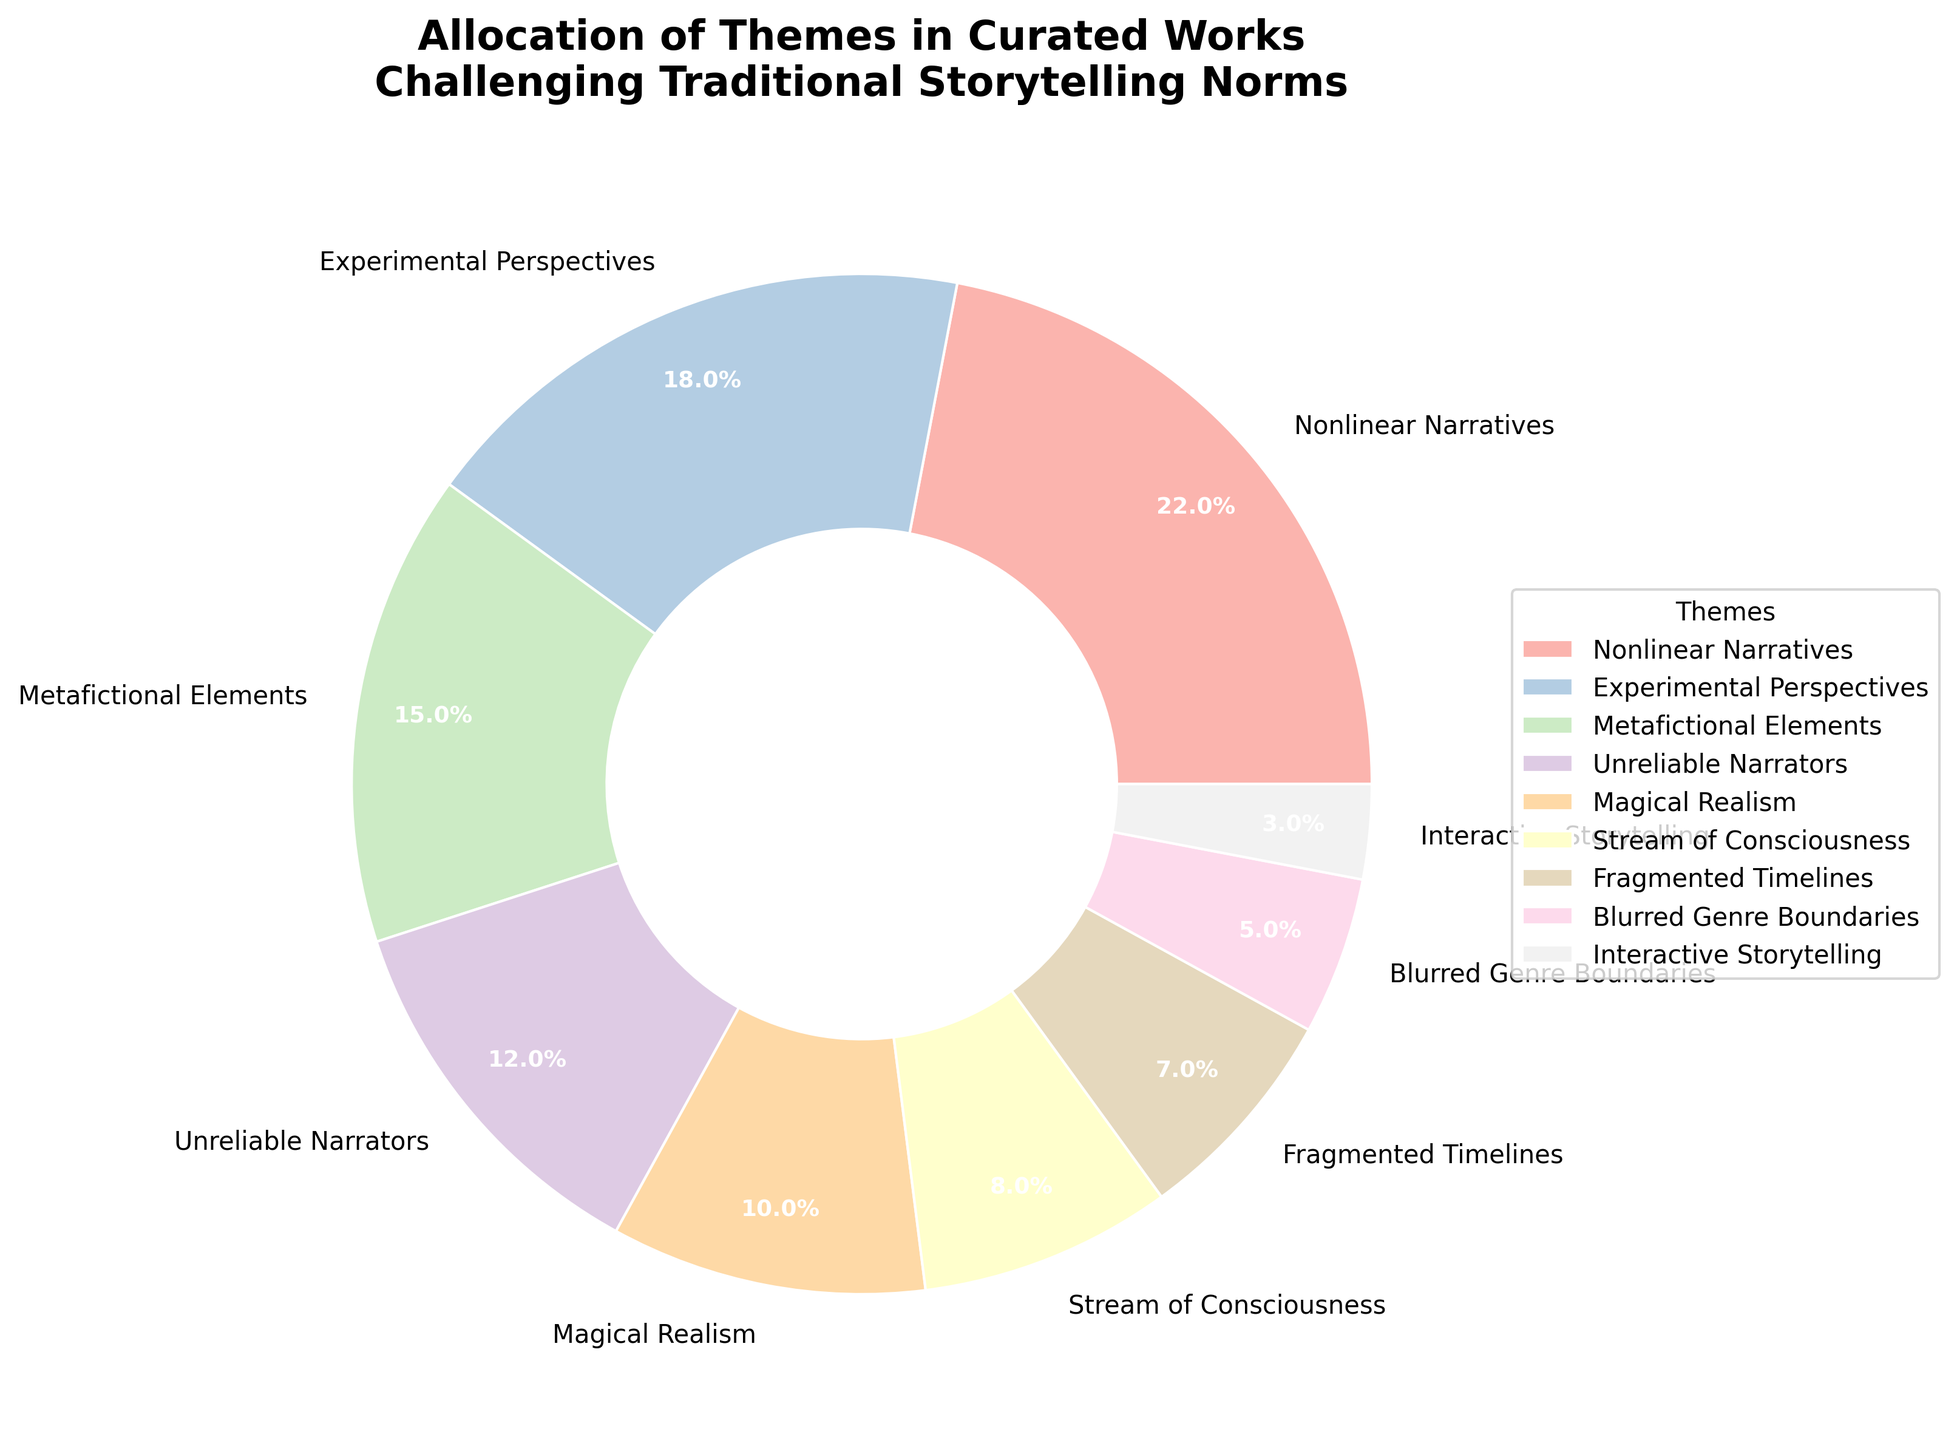What theme has the highest allocation percentage? The largest section of the pie chart indicates the theme with the highest allocation, identified as 'Nonlinear Narratives' with 22%.
Answer: Nonlinear Narratives Which two themes have the closest allocation percentages? Looking at the pie segments closely, 'Experimental Perspectives' has 18% and 'Metafictional Elements' has 15%, which are the closest percentages. The difference between them is 3%.
Answer: Experimental Perspectives and Metafictional Elements What is the combined percentage of 'Magical Realism' and 'Stream of Consciousness'? Sum the percentages for 'Magical Realism' (10%) and 'Stream of Consciousness' (8%). \(10 + 8 = 18\).
Answer: 18% Is the percentage of 'Unreliable Narrators' greater than 'Fragmented Timelines'? Comparing the segments for 'Unreliable Narrators' (12%) and 'Fragmented Timelines' (7%), 12% is greater than 7%.
Answer: Yes Which theme has the smallest allocation percentage? The smallest segment of the pie chart represents 'Interactive Storytelling' with a percentage of 3%.
Answer: Interactive Storytelling How much more percentage does 'Nonlinear Narratives' have compared to 'Blurred Genre Boundaries'? Calculate the difference in percentages: 22% (Nonlinear Narratives) - 5% (Blurred Genre Boundaries) = 17%.
Answer: 17% What is the combined percentage of 'Metafictional Elements', 'Unreliable Narrators', and 'Magical Realism'? Sum the percentages for 'Metafictional Elements' (15%), 'Unreliable Narrators' (12%), and 'Magical Realism' (10%). \(15 + 12 + 10 = 37\).
Answer: 37% What fraction of the total themes is allocated to 'Experimental Perspectives'? Converting the percentage to a fraction, 18% is equivalent to \( \frac{18}{100} \) or simplified \(\frac{9}{50}\).
Answer: \(\frac{9}{50}\) Which theme has a greater allocation: 'Stream of Consciousness' or 'Blurred Genre Boundaries'? Comparing the segments, 'Stream of Consciousness' at 8% is greater than 'Blurred Genre Boundaries' at 5%.
Answer: Stream of Consciousness What is the difference in percentage allocation between the highest and lowest allocated themes? Calculate the difference: 22% (highest for 'Nonlinear Narratives') - 3% (lowest for 'Interactive Storytelling') = 19%.
Answer: 19% 